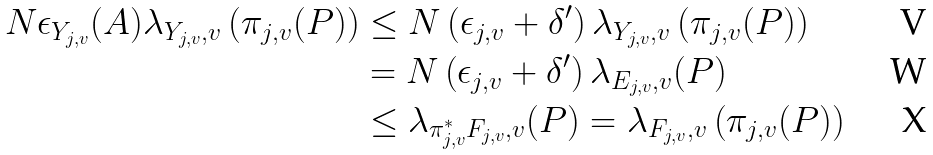Convert formula to latex. <formula><loc_0><loc_0><loc_500><loc_500>N \epsilon _ { Y _ { j , v } } ( A ) \lambda _ { Y _ { j , v } , v } \left ( \pi _ { j , v } ( P ) \right ) & \leq N \left ( \epsilon _ { j , v } + \delta ^ { \prime } \right ) \lambda _ { Y _ { j , v } , v } \left ( \pi _ { j , v } ( P ) \right ) \\ & = N \left ( \epsilon _ { j , v } + \delta ^ { \prime } \right ) \lambda _ { E _ { j , v } , v } ( P ) \\ & \leq \lambda _ { \pi _ { j , v } ^ { * } F _ { j , v } , v } ( P ) = \lambda _ { F _ { j , v } , v } \left ( \pi _ { j , v } ( P ) \right )</formula> 